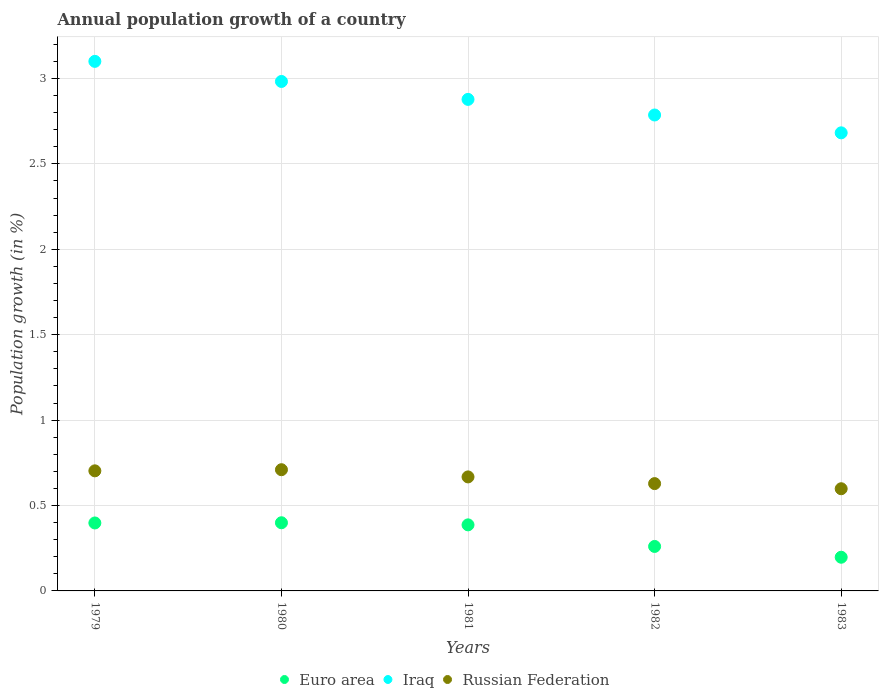How many different coloured dotlines are there?
Ensure brevity in your answer.  3. What is the annual population growth in Russian Federation in 1983?
Give a very brief answer. 0.6. Across all years, what is the maximum annual population growth in Russian Federation?
Give a very brief answer. 0.71. Across all years, what is the minimum annual population growth in Russian Federation?
Offer a very short reply. 0.6. In which year was the annual population growth in Russian Federation minimum?
Your answer should be compact. 1983. What is the total annual population growth in Russian Federation in the graph?
Provide a short and direct response. 3.31. What is the difference between the annual population growth in Iraq in 1979 and that in 1981?
Offer a terse response. 0.22. What is the difference between the annual population growth in Iraq in 1979 and the annual population growth in Euro area in 1982?
Keep it short and to the point. 2.84. What is the average annual population growth in Russian Federation per year?
Your response must be concise. 0.66. In the year 1982, what is the difference between the annual population growth in Iraq and annual population growth in Russian Federation?
Provide a succinct answer. 2.16. What is the ratio of the annual population growth in Russian Federation in 1980 to that in 1983?
Make the answer very short. 1.19. Is the difference between the annual population growth in Iraq in 1980 and 1981 greater than the difference between the annual population growth in Russian Federation in 1980 and 1981?
Make the answer very short. Yes. What is the difference between the highest and the second highest annual population growth in Russian Federation?
Your response must be concise. 0.01. What is the difference between the highest and the lowest annual population growth in Euro area?
Ensure brevity in your answer.  0.2. Is it the case that in every year, the sum of the annual population growth in Russian Federation and annual population growth in Euro area  is greater than the annual population growth in Iraq?
Your answer should be compact. No. Does the annual population growth in Russian Federation monotonically increase over the years?
Provide a succinct answer. No. Is the annual population growth in Iraq strictly greater than the annual population growth in Euro area over the years?
Your response must be concise. Yes. How many dotlines are there?
Ensure brevity in your answer.  3. What is the difference between two consecutive major ticks on the Y-axis?
Offer a very short reply. 0.5. Are the values on the major ticks of Y-axis written in scientific E-notation?
Keep it short and to the point. No. Does the graph contain any zero values?
Provide a short and direct response. No. What is the title of the graph?
Your answer should be compact. Annual population growth of a country. What is the label or title of the X-axis?
Keep it short and to the point. Years. What is the label or title of the Y-axis?
Ensure brevity in your answer.  Population growth (in %). What is the Population growth (in %) in Euro area in 1979?
Offer a very short reply. 0.4. What is the Population growth (in %) in Iraq in 1979?
Make the answer very short. 3.1. What is the Population growth (in %) of Russian Federation in 1979?
Keep it short and to the point. 0.7. What is the Population growth (in %) in Euro area in 1980?
Ensure brevity in your answer.  0.4. What is the Population growth (in %) in Iraq in 1980?
Your response must be concise. 2.98. What is the Population growth (in %) in Russian Federation in 1980?
Provide a short and direct response. 0.71. What is the Population growth (in %) of Euro area in 1981?
Offer a terse response. 0.39. What is the Population growth (in %) in Iraq in 1981?
Ensure brevity in your answer.  2.88. What is the Population growth (in %) of Russian Federation in 1981?
Ensure brevity in your answer.  0.67. What is the Population growth (in %) in Euro area in 1982?
Provide a succinct answer. 0.26. What is the Population growth (in %) of Iraq in 1982?
Your answer should be very brief. 2.79. What is the Population growth (in %) in Russian Federation in 1982?
Offer a terse response. 0.63. What is the Population growth (in %) of Euro area in 1983?
Your answer should be very brief. 0.2. What is the Population growth (in %) of Iraq in 1983?
Keep it short and to the point. 2.68. What is the Population growth (in %) of Russian Federation in 1983?
Keep it short and to the point. 0.6. Across all years, what is the maximum Population growth (in %) in Euro area?
Give a very brief answer. 0.4. Across all years, what is the maximum Population growth (in %) in Iraq?
Make the answer very short. 3.1. Across all years, what is the maximum Population growth (in %) of Russian Federation?
Make the answer very short. 0.71. Across all years, what is the minimum Population growth (in %) in Euro area?
Your answer should be very brief. 0.2. Across all years, what is the minimum Population growth (in %) of Iraq?
Your response must be concise. 2.68. Across all years, what is the minimum Population growth (in %) in Russian Federation?
Your answer should be very brief. 0.6. What is the total Population growth (in %) in Euro area in the graph?
Offer a terse response. 1.64. What is the total Population growth (in %) of Iraq in the graph?
Offer a very short reply. 14.43. What is the total Population growth (in %) of Russian Federation in the graph?
Provide a short and direct response. 3.31. What is the difference between the Population growth (in %) in Euro area in 1979 and that in 1980?
Your answer should be very brief. -0. What is the difference between the Population growth (in %) in Iraq in 1979 and that in 1980?
Offer a very short reply. 0.12. What is the difference between the Population growth (in %) in Russian Federation in 1979 and that in 1980?
Make the answer very short. -0.01. What is the difference between the Population growth (in %) in Euro area in 1979 and that in 1981?
Offer a very short reply. 0.01. What is the difference between the Population growth (in %) in Iraq in 1979 and that in 1981?
Your answer should be very brief. 0.22. What is the difference between the Population growth (in %) of Russian Federation in 1979 and that in 1981?
Your response must be concise. 0.04. What is the difference between the Population growth (in %) of Euro area in 1979 and that in 1982?
Your answer should be very brief. 0.14. What is the difference between the Population growth (in %) of Iraq in 1979 and that in 1982?
Make the answer very short. 0.31. What is the difference between the Population growth (in %) in Russian Federation in 1979 and that in 1982?
Provide a short and direct response. 0.07. What is the difference between the Population growth (in %) of Euro area in 1979 and that in 1983?
Ensure brevity in your answer.  0.2. What is the difference between the Population growth (in %) in Iraq in 1979 and that in 1983?
Ensure brevity in your answer.  0.42. What is the difference between the Population growth (in %) in Russian Federation in 1979 and that in 1983?
Make the answer very short. 0.1. What is the difference between the Population growth (in %) in Euro area in 1980 and that in 1981?
Your answer should be compact. 0.01. What is the difference between the Population growth (in %) of Iraq in 1980 and that in 1981?
Provide a short and direct response. 0.1. What is the difference between the Population growth (in %) in Russian Federation in 1980 and that in 1981?
Offer a terse response. 0.04. What is the difference between the Population growth (in %) in Euro area in 1980 and that in 1982?
Your response must be concise. 0.14. What is the difference between the Population growth (in %) in Iraq in 1980 and that in 1982?
Offer a terse response. 0.2. What is the difference between the Population growth (in %) in Russian Federation in 1980 and that in 1982?
Offer a terse response. 0.08. What is the difference between the Population growth (in %) in Euro area in 1980 and that in 1983?
Ensure brevity in your answer.  0.2. What is the difference between the Population growth (in %) of Iraq in 1980 and that in 1983?
Give a very brief answer. 0.3. What is the difference between the Population growth (in %) of Russian Federation in 1980 and that in 1983?
Offer a very short reply. 0.11. What is the difference between the Population growth (in %) in Euro area in 1981 and that in 1982?
Provide a succinct answer. 0.13. What is the difference between the Population growth (in %) in Iraq in 1981 and that in 1982?
Your answer should be very brief. 0.09. What is the difference between the Population growth (in %) in Russian Federation in 1981 and that in 1982?
Provide a succinct answer. 0.04. What is the difference between the Population growth (in %) of Euro area in 1981 and that in 1983?
Offer a terse response. 0.19. What is the difference between the Population growth (in %) in Iraq in 1981 and that in 1983?
Keep it short and to the point. 0.2. What is the difference between the Population growth (in %) of Russian Federation in 1981 and that in 1983?
Give a very brief answer. 0.07. What is the difference between the Population growth (in %) in Euro area in 1982 and that in 1983?
Offer a very short reply. 0.06. What is the difference between the Population growth (in %) in Iraq in 1982 and that in 1983?
Offer a very short reply. 0.1. What is the difference between the Population growth (in %) in Euro area in 1979 and the Population growth (in %) in Iraq in 1980?
Keep it short and to the point. -2.58. What is the difference between the Population growth (in %) in Euro area in 1979 and the Population growth (in %) in Russian Federation in 1980?
Make the answer very short. -0.31. What is the difference between the Population growth (in %) of Iraq in 1979 and the Population growth (in %) of Russian Federation in 1980?
Ensure brevity in your answer.  2.39. What is the difference between the Population growth (in %) in Euro area in 1979 and the Population growth (in %) in Iraq in 1981?
Your answer should be compact. -2.48. What is the difference between the Population growth (in %) of Euro area in 1979 and the Population growth (in %) of Russian Federation in 1981?
Ensure brevity in your answer.  -0.27. What is the difference between the Population growth (in %) in Iraq in 1979 and the Population growth (in %) in Russian Federation in 1981?
Offer a terse response. 2.43. What is the difference between the Population growth (in %) in Euro area in 1979 and the Population growth (in %) in Iraq in 1982?
Offer a very short reply. -2.39. What is the difference between the Population growth (in %) in Euro area in 1979 and the Population growth (in %) in Russian Federation in 1982?
Provide a short and direct response. -0.23. What is the difference between the Population growth (in %) in Iraq in 1979 and the Population growth (in %) in Russian Federation in 1982?
Keep it short and to the point. 2.47. What is the difference between the Population growth (in %) of Euro area in 1979 and the Population growth (in %) of Iraq in 1983?
Your answer should be compact. -2.28. What is the difference between the Population growth (in %) of Euro area in 1979 and the Population growth (in %) of Russian Federation in 1983?
Ensure brevity in your answer.  -0.2. What is the difference between the Population growth (in %) in Iraq in 1979 and the Population growth (in %) in Russian Federation in 1983?
Your answer should be very brief. 2.5. What is the difference between the Population growth (in %) of Euro area in 1980 and the Population growth (in %) of Iraq in 1981?
Give a very brief answer. -2.48. What is the difference between the Population growth (in %) of Euro area in 1980 and the Population growth (in %) of Russian Federation in 1981?
Provide a succinct answer. -0.27. What is the difference between the Population growth (in %) in Iraq in 1980 and the Population growth (in %) in Russian Federation in 1981?
Your answer should be very brief. 2.32. What is the difference between the Population growth (in %) in Euro area in 1980 and the Population growth (in %) in Iraq in 1982?
Offer a terse response. -2.39. What is the difference between the Population growth (in %) of Euro area in 1980 and the Population growth (in %) of Russian Federation in 1982?
Provide a succinct answer. -0.23. What is the difference between the Population growth (in %) in Iraq in 1980 and the Population growth (in %) in Russian Federation in 1982?
Provide a short and direct response. 2.35. What is the difference between the Population growth (in %) in Euro area in 1980 and the Population growth (in %) in Iraq in 1983?
Offer a terse response. -2.28. What is the difference between the Population growth (in %) in Euro area in 1980 and the Population growth (in %) in Russian Federation in 1983?
Offer a terse response. -0.2. What is the difference between the Population growth (in %) in Iraq in 1980 and the Population growth (in %) in Russian Federation in 1983?
Your answer should be very brief. 2.38. What is the difference between the Population growth (in %) of Euro area in 1981 and the Population growth (in %) of Iraq in 1982?
Provide a succinct answer. -2.4. What is the difference between the Population growth (in %) in Euro area in 1981 and the Population growth (in %) in Russian Federation in 1982?
Give a very brief answer. -0.24. What is the difference between the Population growth (in %) in Iraq in 1981 and the Population growth (in %) in Russian Federation in 1982?
Provide a succinct answer. 2.25. What is the difference between the Population growth (in %) in Euro area in 1981 and the Population growth (in %) in Iraq in 1983?
Make the answer very short. -2.3. What is the difference between the Population growth (in %) in Euro area in 1981 and the Population growth (in %) in Russian Federation in 1983?
Your answer should be very brief. -0.21. What is the difference between the Population growth (in %) in Iraq in 1981 and the Population growth (in %) in Russian Federation in 1983?
Make the answer very short. 2.28. What is the difference between the Population growth (in %) in Euro area in 1982 and the Population growth (in %) in Iraq in 1983?
Keep it short and to the point. -2.42. What is the difference between the Population growth (in %) of Euro area in 1982 and the Population growth (in %) of Russian Federation in 1983?
Your answer should be compact. -0.34. What is the difference between the Population growth (in %) of Iraq in 1982 and the Population growth (in %) of Russian Federation in 1983?
Offer a very short reply. 2.19. What is the average Population growth (in %) in Euro area per year?
Offer a terse response. 0.33. What is the average Population growth (in %) of Iraq per year?
Your answer should be compact. 2.89. What is the average Population growth (in %) of Russian Federation per year?
Provide a short and direct response. 0.66. In the year 1979, what is the difference between the Population growth (in %) of Euro area and Population growth (in %) of Iraq?
Provide a succinct answer. -2.7. In the year 1979, what is the difference between the Population growth (in %) of Euro area and Population growth (in %) of Russian Federation?
Offer a very short reply. -0.31. In the year 1979, what is the difference between the Population growth (in %) in Iraq and Population growth (in %) in Russian Federation?
Ensure brevity in your answer.  2.4. In the year 1980, what is the difference between the Population growth (in %) in Euro area and Population growth (in %) in Iraq?
Your answer should be very brief. -2.58. In the year 1980, what is the difference between the Population growth (in %) of Euro area and Population growth (in %) of Russian Federation?
Provide a short and direct response. -0.31. In the year 1980, what is the difference between the Population growth (in %) in Iraq and Population growth (in %) in Russian Federation?
Ensure brevity in your answer.  2.27. In the year 1981, what is the difference between the Population growth (in %) of Euro area and Population growth (in %) of Iraq?
Your answer should be very brief. -2.49. In the year 1981, what is the difference between the Population growth (in %) in Euro area and Population growth (in %) in Russian Federation?
Make the answer very short. -0.28. In the year 1981, what is the difference between the Population growth (in %) in Iraq and Population growth (in %) in Russian Federation?
Provide a short and direct response. 2.21. In the year 1982, what is the difference between the Population growth (in %) in Euro area and Population growth (in %) in Iraq?
Your response must be concise. -2.53. In the year 1982, what is the difference between the Population growth (in %) in Euro area and Population growth (in %) in Russian Federation?
Offer a terse response. -0.37. In the year 1982, what is the difference between the Population growth (in %) of Iraq and Population growth (in %) of Russian Federation?
Provide a succinct answer. 2.16. In the year 1983, what is the difference between the Population growth (in %) in Euro area and Population growth (in %) in Iraq?
Provide a short and direct response. -2.48. In the year 1983, what is the difference between the Population growth (in %) in Euro area and Population growth (in %) in Russian Federation?
Your answer should be compact. -0.4. In the year 1983, what is the difference between the Population growth (in %) in Iraq and Population growth (in %) in Russian Federation?
Offer a very short reply. 2.08. What is the ratio of the Population growth (in %) in Iraq in 1979 to that in 1980?
Your response must be concise. 1.04. What is the ratio of the Population growth (in %) in Euro area in 1979 to that in 1981?
Your answer should be very brief. 1.03. What is the ratio of the Population growth (in %) of Iraq in 1979 to that in 1981?
Provide a succinct answer. 1.08. What is the ratio of the Population growth (in %) in Russian Federation in 1979 to that in 1981?
Give a very brief answer. 1.05. What is the ratio of the Population growth (in %) of Euro area in 1979 to that in 1982?
Offer a very short reply. 1.53. What is the ratio of the Population growth (in %) in Iraq in 1979 to that in 1982?
Ensure brevity in your answer.  1.11. What is the ratio of the Population growth (in %) of Russian Federation in 1979 to that in 1982?
Ensure brevity in your answer.  1.12. What is the ratio of the Population growth (in %) in Euro area in 1979 to that in 1983?
Your answer should be compact. 2.02. What is the ratio of the Population growth (in %) of Iraq in 1979 to that in 1983?
Your response must be concise. 1.16. What is the ratio of the Population growth (in %) in Russian Federation in 1979 to that in 1983?
Offer a very short reply. 1.18. What is the ratio of the Population growth (in %) of Euro area in 1980 to that in 1981?
Provide a succinct answer. 1.03. What is the ratio of the Population growth (in %) of Iraq in 1980 to that in 1981?
Keep it short and to the point. 1.04. What is the ratio of the Population growth (in %) in Russian Federation in 1980 to that in 1981?
Provide a succinct answer. 1.06. What is the ratio of the Population growth (in %) of Euro area in 1980 to that in 1982?
Keep it short and to the point. 1.53. What is the ratio of the Population growth (in %) in Iraq in 1980 to that in 1982?
Provide a short and direct response. 1.07. What is the ratio of the Population growth (in %) in Russian Federation in 1980 to that in 1982?
Provide a short and direct response. 1.13. What is the ratio of the Population growth (in %) in Euro area in 1980 to that in 1983?
Your answer should be compact. 2.02. What is the ratio of the Population growth (in %) of Iraq in 1980 to that in 1983?
Your answer should be very brief. 1.11. What is the ratio of the Population growth (in %) of Russian Federation in 1980 to that in 1983?
Your answer should be compact. 1.19. What is the ratio of the Population growth (in %) of Euro area in 1981 to that in 1982?
Give a very brief answer. 1.49. What is the ratio of the Population growth (in %) in Iraq in 1981 to that in 1982?
Ensure brevity in your answer.  1.03. What is the ratio of the Population growth (in %) in Russian Federation in 1981 to that in 1982?
Give a very brief answer. 1.06. What is the ratio of the Population growth (in %) in Euro area in 1981 to that in 1983?
Make the answer very short. 1.96. What is the ratio of the Population growth (in %) of Iraq in 1981 to that in 1983?
Your response must be concise. 1.07. What is the ratio of the Population growth (in %) in Russian Federation in 1981 to that in 1983?
Make the answer very short. 1.12. What is the ratio of the Population growth (in %) in Euro area in 1982 to that in 1983?
Make the answer very short. 1.32. What is the ratio of the Population growth (in %) in Iraq in 1982 to that in 1983?
Ensure brevity in your answer.  1.04. What is the ratio of the Population growth (in %) in Russian Federation in 1982 to that in 1983?
Your answer should be compact. 1.05. What is the difference between the highest and the second highest Population growth (in %) in Euro area?
Ensure brevity in your answer.  0. What is the difference between the highest and the second highest Population growth (in %) in Iraq?
Offer a very short reply. 0.12. What is the difference between the highest and the second highest Population growth (in %) of Russian Federation?
Make the answer very short. 0.01. What is the difference between the highest and the lowest Population growth (in %) in Euro area?
Offer a very short reply. 0.2. What is the difference between the highest and the lowest Population growth (in %) of Iraq?
Ensure brevity in your answer.  0.42. What is the difference between the highest and the lowest Population growth (in %) of Russian Federation?
Provide a succinct answer. 0.11. 